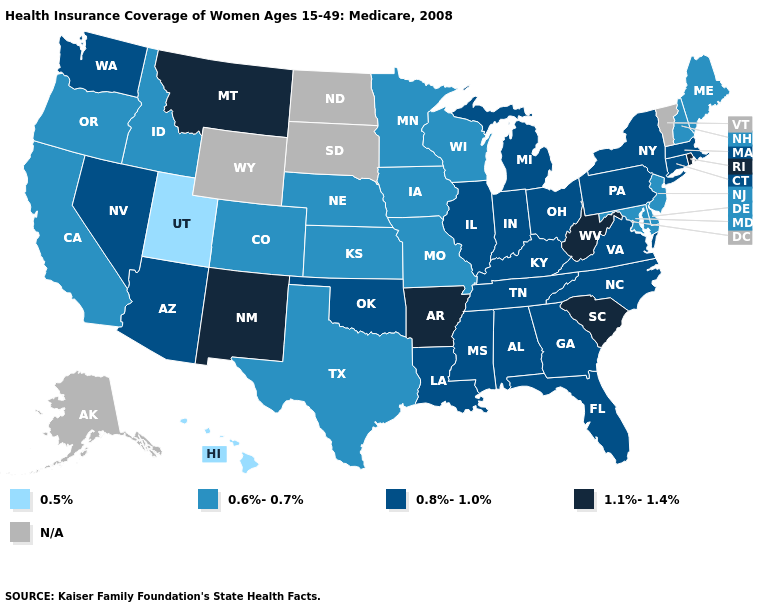What is the lowest value in states that border Tennessee?
Write a very short answer. 0.6%-0.7%. What is the lowest value in states that border Illinois?
Write a very short answer. 0.6%-0.7%. Does Tennessee have the lowest value in the South?
Write a very short answer. No. What is the highest value in the South ?
Quick response, please. 1.1%-1.4%. How many symbols are there in the legend?
Be succinct. 5. Does Nevada have the highest value in the USA?
Quick response, please. No. Is the legend a continuous bar?
Write a very short answer. No. Name the states that have a value in the range 1.1%-1.4%?
Quick response, please. Arkansas, Montana, New Mexico, Rhode Island, South Carolina, West Virginia. What is the value of North Carolina?
Be succinct. 0.8%-1.0%. What is the highest value in states that border North Dakota?
Short answer required. 1.1%-1.4%. Which states have the lowest value in the USA?
Keep it brief. Hawaii, Utah. Which states have the highest value in the USA?
Answer briefly. Arkansas, Montana, New Mexico, Rhode Island, South Carolina, West Virginia. What is the value of Washington?
Short answer required. 0.8%-1.0%. Which states have the lowest value in the MidWest?
Quick response, please. Iowa, Kansas, Minnesota, Missouri, Nebraska, Wisconsin. Does the map have missing data?
Be succinct. Yes. 